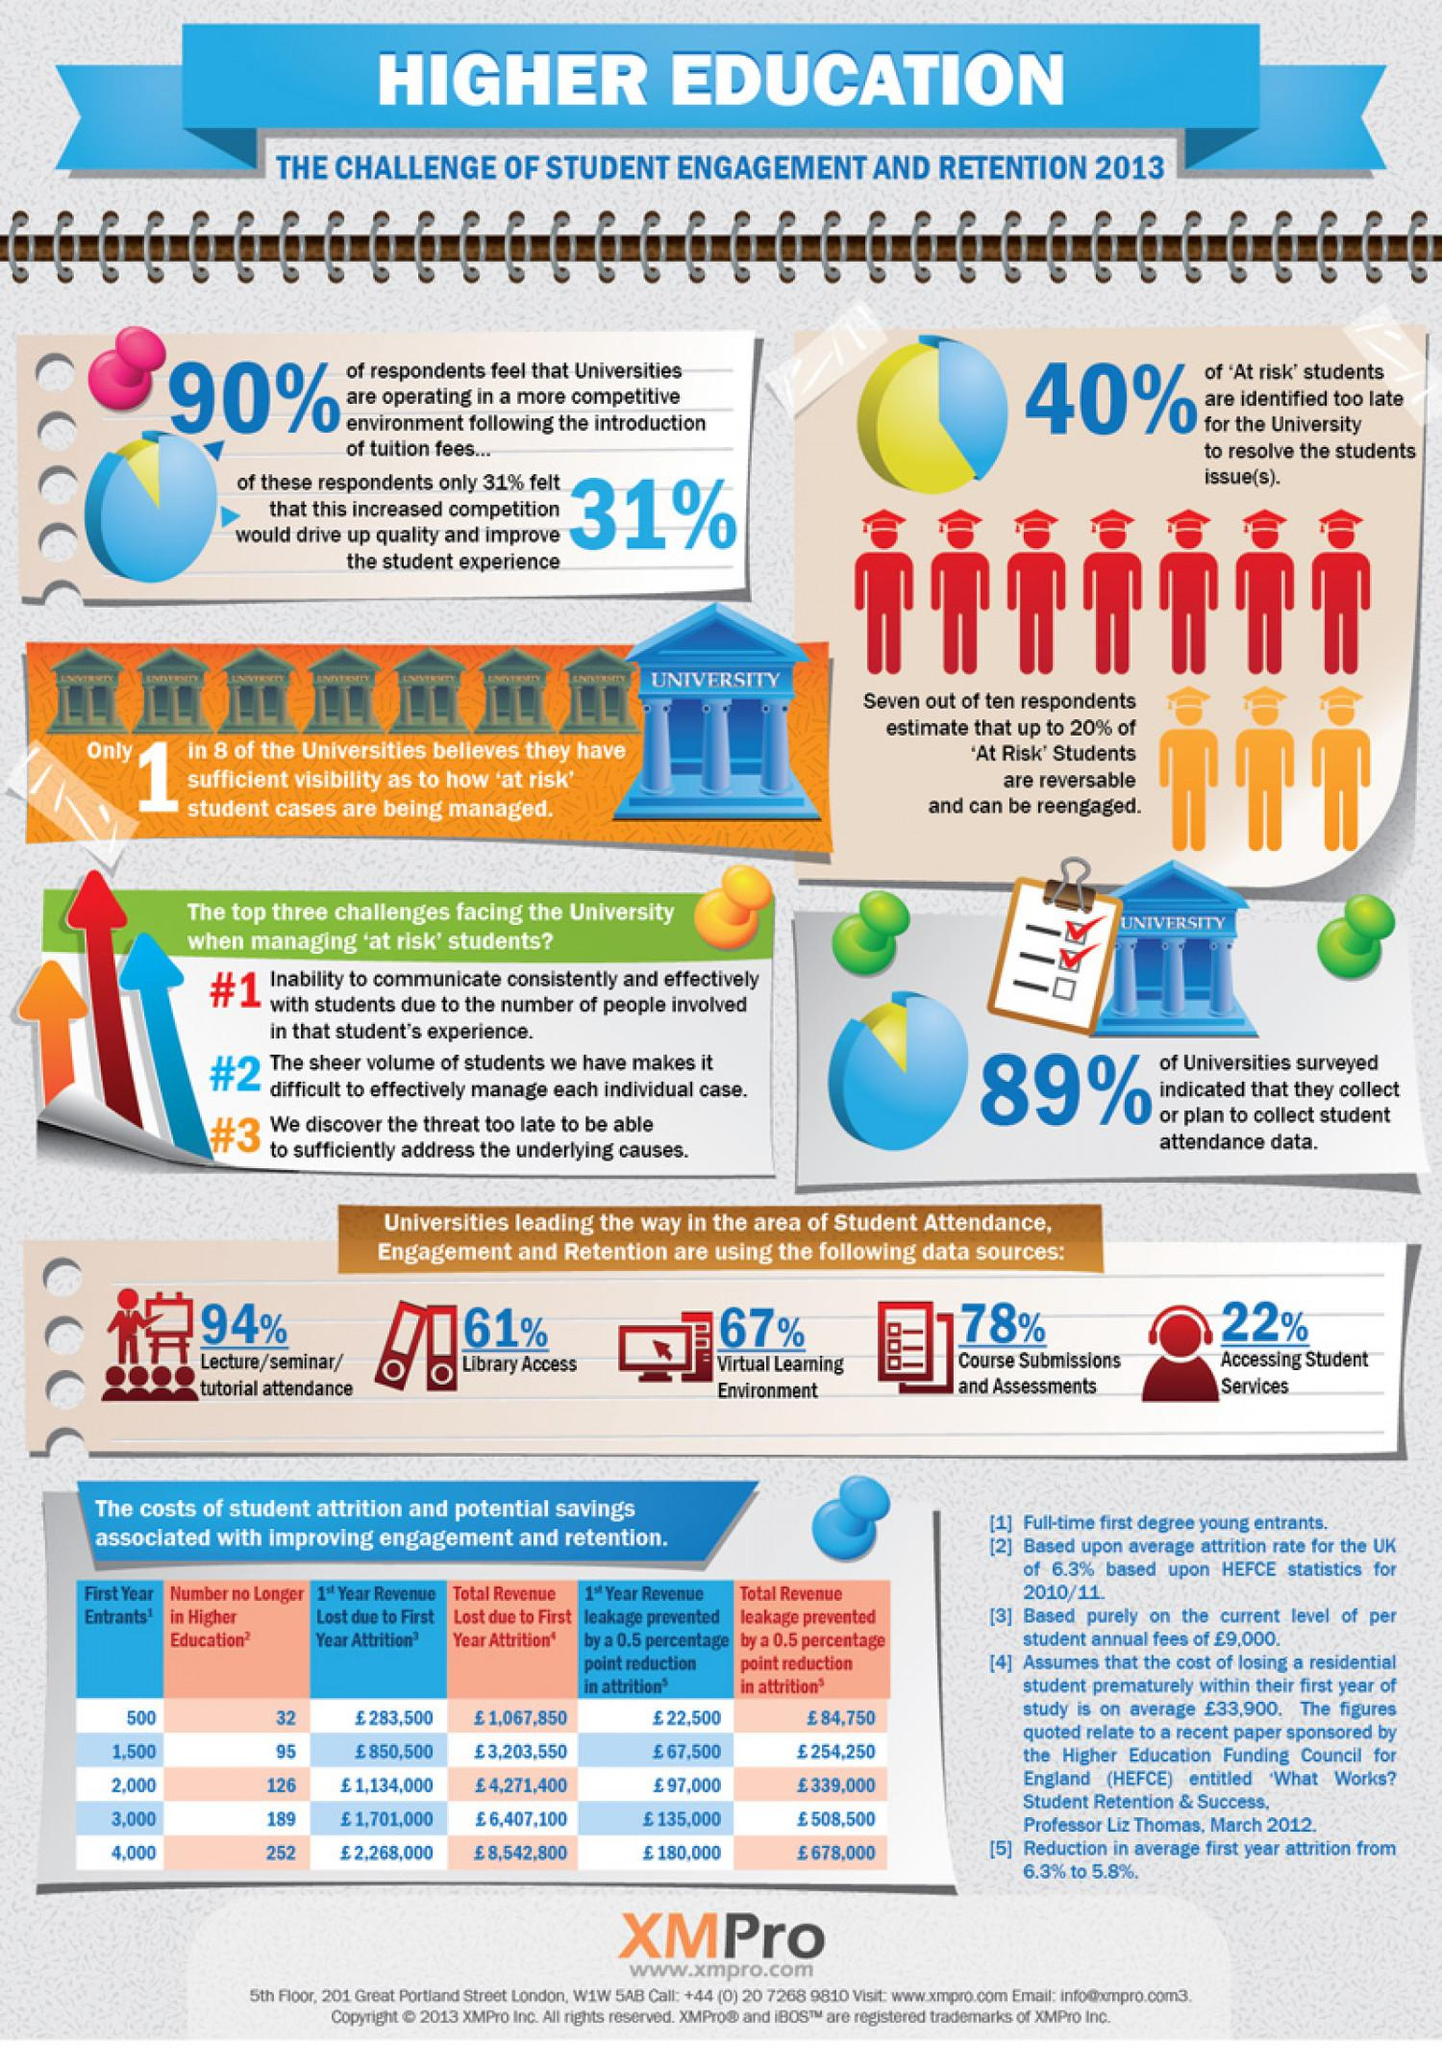Identify some key points in this picture. The first and most significant challenge faced by universities when managing "at-risk" students is the inability to communicate consistently and effectively. According to the survey, a significant percentage of universities, which is 89%, collect or have plans to collect student attendance data. 